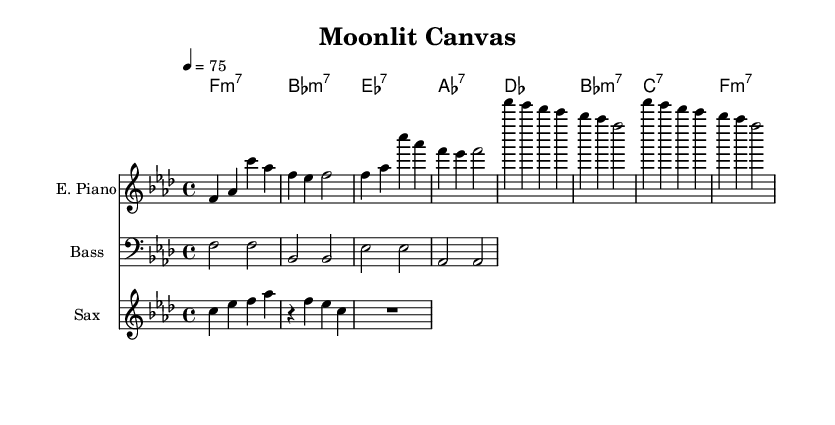What is the key signature of this music? The key signature is indicated in the global music block where "f minor" is stated. This indicates that there are four flats in the key signature: B flat, E flat, A flat, and D flat.
Answer: F minor What is the time signature of this music? The time signature is found in the global section with "4/4" written, which means there are four beats in each measure and the quarter note gets one beat.
Answer: 4/4 What is the tempo marking of this piece? The tempo marking is found in the global section where it states "4 = 75", which indicates the beats per minute for the piece.
Answer: 75 What is the instrument labeled as in the score? The score includes the names of the instruments; specifically, "E. Piano" is the label for the electric piano staff.
Answer: E. Piano Which chord is played in the first measure of the verse? The first measure of the chord names shows "f:m7" indicating that an F minor 7 chord is played.
Answer: F minor 7 How many measures does the saxophone riff consist of? The saxophone riff contains a single measure since it is followed by a rest, as indicated by "R1" after the riff notation.
Answer: 1 Which instrument plays the bass line? The instrument part labeled "Bass" is indicated in the score, referring to the bass guitar that provides the bass line for the music.
Answer: Bass 